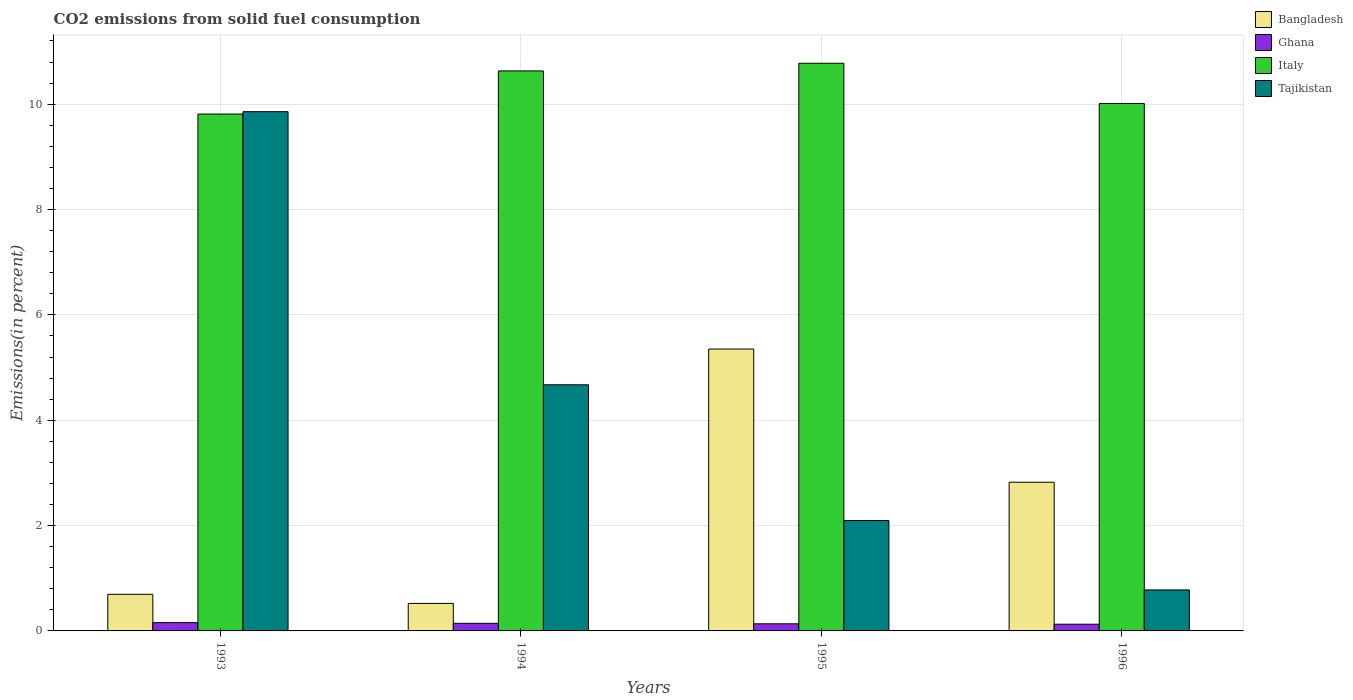How many groups of bars are there?
Give a very brief answer. 4. How many bars are there on the 3rd tick from the left?
Offer a very short reply. 4. How many bars are there on the 4th tick from the right?
Your answer should be compact. 4. What is the total CO2 emitted in Bangladesh in 1994?
Make the answer very short. 0.52. Across all years, what is the maximum total CO2 emitted in Tajikistan?
Your answer should be compact. 9.86. Across all years, what is the minimum total CO2 emitted in Ghana?
Offer a very short reply. 0.13. In which year was the total CO2 emitted in Italy minimum?
Provide a short and direct response. 1993. What is the total total CO2 emitted in Ghana in the graph?
Your answer should be compact. 0.56. What is the difference between the total CO2 emitted in Ghana in 1993 and that in 1996?
Keep it short and to the point. 0.03. What is the difference between the total CO2 emitted in Tajikistan in 1994 and the total CO2 emitted in Italy in 1995?
Make the answer very short. -6.1. What is the average total CO2 emitted in Tajikistan per year?
Provide a succinct answer. 4.35. In the year 1995, what is the difference between the total CO2 emitted in Tajikistan and total CO2 emitted in Italy?
Your answer should be compact. -8.68. In how many years, is the total CO2 emitted in Italy greater than 1.6 %?
Your answer should be very brief. 4. What is the ratio of the total CO2 emitted in Bangladesh in 1993 to that in 1994?
Your answer should be very brief. 1.33. What is the difference between the highest and the second highest total CO2 emitted in Italy?
Make the answer very short. 0.15. What is the difference between the highest and the lowest total CO2 emitted in Bangladesh?
Ensure brevity in your answer.  4.83. What does the 3rd bar from the right in 1993 represents?
Your response must be concise. Ghana. Is it the case that in every year, the sum of the total CO2 emitted in Ghana and total CO2 emitted in Tajikistan is greater than the total CO2 emitted in Bangladesh?
Give a very brief answer. No. How many bars are there?
Provide a short and direct response. 16. What is the difference between two consecutive major ticks on the Y-axis?
Keep it short and to the point. 2. Are the values on the major ticks of Y-axis written in scientific E-notation?
Your answer should be very brief. No. Does the graph contain any zero values?
Offer a very short reply. No. How many legend labels are there?
Give a very brief answer. 4. What is the title of the graph?
Make the answer very short. CO2 emissions from solid fuel consumption. What is the label or title of the Y-axis?
Keep it short and to the point. Emissions(in percent). What is the Emissions(in percent) in Bangladesh in 1993?
Offer a very short reply. 0.7. What is the Emissions(in percent) of Ghana in 1993?
Your answer should be very brief. 0.16. What is the Emissions(in percent) of Italy in 1993?
Give a very brief answer. 9.81. What is the Emissions(in percent) of Tajikistan in 1993?
Provide a succinct answer. 9.86. What is the Emissions(in percent) of Bangladesh in 1994?
Give a very brief answer. 0.52. What is the Emissions(in percent) in Ghana in 1994?
Offer a terse response. 0.14. What is the Emissions(in percent) in Italy in 1994?
Provide a short and direct response. 10.63. What is the Emissions(in percent) in Tajikistan in 1994?
Keep it short and to the point. 4.67. What is the Emissions(in percent) in Bangladesh in 1995?
Offer a terse response. 5.35. What is the Emissions(in percent) in Ghana in 1995?
Ensure brevity in your answer.  0.14. What is the Emissions(in percent) in Italy in 1995?
Make the answer very short. 10.78. What is the Emissions(in percent) of Tajikistan in 1995?
Your response must be concise. 2.1. What is the Emissions(in percent) in Bangladesh in 1996?
Offer a terse response. 2.82. What is the Emissions(in percent) in Ghana in 1996?
Your answer should be very brief. 0.13. What is the Emissions(in percent) in Italy in 1996?
Provide a succinct answer. 10.01. What is the Emissions(in percent) in Tajikistan in 1996?
Your answer should be very brief. 0.78. Across all years, what is the maximum Emissions(in percent) in Bangladesh?
Make the answer very short. 5.35. Across all years, what is the maximum Emissions(in percent) of Ghana?
Your answer should be very brief. 0.16. Across all years, what is the maximum Emissions(in percent) in Italy?
Make the answer very short. 10.78. Across all years, what is the maximum Emissions(in percent) of Tajikistan?
Your response must be concise. 9.86. Across all years, what is the minimum Emissions(in percent) of Bangladesh?
Offer a very short reply. 0.52. Across all years, what is the minimum Emissions(in percent) of Ghana?
Offer a terse response. 0.13. Across all years, what is the minimum Emissions(in percent) in Italy?
Provide a succinct answer. 9.81. Across all years, what is the minimum Emissions(in percent) of Tajikistan?
Make the answer very short. 0.78. What is the total Emissions(in percent) in Bangladesh in the graph?
Provide a succinct answer. 9.39. What is the total Emissions(in percent) in Ghana in the graph?
Keep it short and to the point. 0.56. What is the total Emissions(in percent) in Italy in the graph?
Your response must be concise. 41.24. What is the total Emissions(in percent) of Tajikistan in the graph?
Your answer should be very brief. 17.41. What is the difference between the Emissions(in percent) in Bangladesh in 1993 and that in 1994?
Give a very brief answer. 0.17. What is the difference between the Emissions(in percent) of Ghana in 1993 and that in 1994?
Offer a terse response. 0.01. What is the difference between the Emissions(in percent) in Italy in 1993 and that in 1994?
Your response must be concise. -0.82. What is the difference between the Emissions(in percent) of Tajikistan in 1993 and that in 1994?
Provide a short and direct response. 5.19. What is the difference between the Emissions(in percent) of Bangladesh in 1993 and that in 1995?
Keep it short and to the point. -4.66. What is the difference between the Emissions(in percent) of Ghana in 1993 and that in 1995?
Offer a very short reply. 0.02. What is the difference between the Emissions(in percent) in Italy in 1993 and that in 1995?
Provide a short and direct response. -0.96. What is the difference between the Emissions(in percent) of Tajikistan in 1993 and that in 1995?
Keep it short and to the point. 7.76. What is the difference between the Emissions(in percent) in Bangladesh in 1993 and that in 1996?
Keep it short and to the point. -2.13. What is the difference between the Emissions(in percent) in Ghana in 1993 and that in 1996?
Your answer should be very brief. 0.03. What is the difference between the Emissions(in percent) of Italy in 1993 and that in 1996?
Ensure brevity in your answer.  -0.2. What is the difference between the Emissions(in percent) in Tajikistan in 1993 and that in 1996?
Make the answer very short. 9.08. What is the difference between the Emissions(in percent) in Bangladesh in 1994 and that in 1995?
Make the answer very short. -4.83. What is the difference between the Emissions(in percent) in Ghana in 1994 and that in 1995?
Provide a succinct answer. 0.01. What is the difference between the Emissions(in percent) of Italy in 1994 and that in 1995?
Make the answer very short. -0.15. What is the difference between the Emissions(in percent) of Tajikistan in 1994 and that in 1995?
Give a very brief answer. 2.58. What is the difference between the Emissions(in percent) of Bangladesh in 1994 and that in 1996?
Make the answer very short. -2.3. What is the difference between the Emissions(in percent) in Ghana in 1994 and that in 1996?
Provide a short and direct response. 0.02. What is the difference between the Emissions(in percent) in Italy in 1994 and that in 1996?
Give a very brief answer. 0.62. What is the difference between the Emissions(in percent) in Tajikistan in 1994 and that in 1996?
Your response must be concise. 3.89. What is the difference between the Emissions(in percent) in Bangladesh in 1995 and that in 1996?
Ensure brevity in your answer.  2.53. What is the difference between the Emissions(in percent) in Ghana in 1995 and that in 1996?
Your answer should be compact. 0.01. What is the difference between the Emissions(in percent) of Italy in 1995 and that in 1996?
Give a very brief answer. 0.76. What is the difference between the Emissions(in percent) of Tajikistan in 1995 and that in 1996?
Your answer should be very brief. 1.32. What is the difference between the Emissions(in percent) of Bangladesh in 1993 and the Emissions(in percent) of Ghana in 1994?
Your answer should be compact. 0.55. What is the difference between the Emissions(in percent) in Bangladesh in 1993 and the Emissions(in percent) in Italy in 1994?
Offer a very short reply. -9.94. What is the difference between the Emissions(in percent) of Bangladesh in 1993 and the Emissions(in percent) of Tajikistan in 1994?
Keep it short and to the point. -3.98. What is the difference between the Emissions(in percent) in Ghana in 1993 and the Emissions(in percent) in Italy in 1994?
Make the answer very short. -10.47. What is the difference between the Emissions(in percent) of Ghana in 1993 and the Emissions(in percent) of Tajikistan in 1994?
Provide a short and direct response. -4.52. What is the difference between the Emissions(in percent) in Italy in 1993 and the Emissions(in percent) in Tajikistan in 1994?
Your answer should be very brief. 5.14. What is the difference between the Emissions(in percent) of Bangladesh in 1993 and the Emissions(in percent) of Ghana in 1995?
Keep it short and to the point. 0.56. What is the difference between the Emissions(in percent) of Bangladesh in 1993 and the Emissions(in percent) of Italy in 1995?
Make the answer very short. -10.08. What is the difference between the Emissions(in percent) in Bangladesh in 1993 and the Emissions(in percent) in Tajikistan in 1995?
Ensure brevity in your answer.  -1.4. What is the difference between the Emissions(in percent) in Ghana in 1993 and the Emissions(in percent) in Italy in 1995?
Offer a very short reply. -10.62. What is the difference between the Emissions(in percent) of Ghana in 1993 and the Emissions(in percent) of Tajikistan in 1995?
Your answer should be compact. -1.94. What is the difference between the Emissions(in percent) of Italy in 1993 and the Emissions(in percent) of Tajikistan in 1995?
Offer a very short reply. 7.72. What is the difference between the Emissions(in percent) of Bangladesh in 1993 and the Emissions(in percent) of Ghana in 1996?
Your answer should be very brief. 0.57. What is the difference between the Emissions(in percent) of Bangladesh in 1993 and the Emissions(in percent) of Italy in 1996?
Your answer should be very brief. -9.32. What is the difference between the Emissions(in percent) of Bangladesh in 1993 and the Emissions(in percent) of Tajikistan in 1996?
Ensure brevity in your answer.  -0.08. What is the difference between the Emissions(in percent) in Ghana in 1993 and the Emissions(in percent) in Italy in 1996?
Your answer should be compact. -9.86. What is the difference between the Emissions(in percent) in Ghana in 1993 and the Emissions(in percent) in Tajikistan in 1996?
Provide a succinct answer. -0.62. What is the difference between the Emissions(in percent) in Italy in 1993 and the Emissions(in percent) in Tajikistan in 1996?
Provide a short and direct response. 9.03. What is the difference between the Emissions(in percent) of Bangladesh in 1994 and the Emissions(in percent) of Ghana in 1995?
Provide a short and direct response. 0.39. What is the difference between the Emissions(in percent) of Bangladesh in 1994 and the Emissions(in percent) of Italy in 1995?
Provide a succinct answer. -10.26. What is the difference between the Emissions(in percent) of Bangladesh in 1994 and the Emissions(in percent) of Tajikistan in 1995?
Your answer should be compact. -1.57. What is the difference between the Emissions(in percent) of Ghana in 1994 and the Emissions(in percent) of Italy in 1995?
Give a very brief answer. -10.63. What is the difference between the Emissions(in percent) of Ghana in 1994 and the Emissions(in percent) of Tajikistan in 1995?
Make the answer very short. -1.95. What is the difference between the Emissions(in percent) in Italy in 1994 and the Emissions(in percent) in Tajikistan in 1995?
Provide a succinct answer. 8.54. What is the difference between the Emissions(in percent) in Bangladesh in 1994 and the Emissions(in percent) in Ghana in 1996?
Give a very brief answer. 0.39. What is the difference between the Emissions(in percent) of Bangladesh in 1994 and the Emissions(in percent) of Italy in 1996?
Your answer should be compact. -9.49. What is the difference between the Emissions(in percent) in Bangladesh in 1994 and the Emissions(in percent) in Tajikistan in 1996?
Keep it short and to the point. -0.26. What is the difference between the Emissions(in percent) of Ghana in 1994 and the Emissions(in percent) of Italy in 1996?
Keep it short and to the point. -9.87. What is the difference between the Emissions(in percent) of Ghana in 1994 and the Emissions(in percent) of Tajikistan in 1996?
Your response must be concise. -0.63. What is the difference between the Emissions(in percent) of Italy in 1994 and the Emissions(in percent) of Tajikistan in 1996?
Offer a terse response. 9.85. What is the difference between the Emissions(in percent) in Bangladesh in 1995 and the Emissions(in percent) in Ghana in 1996?
Provide a short and direct response. 5.22. What is the difference between the Emissions(in percent) in Bangladesh in 1995 and the Emissions(in percent) in Italy in 1996?
Your answer should be compact. -4.66. What is the difference between the Emissions(in percent) of Bangladesh in 1995 and the Emissions(in percent) of Tajikistan in 1996?
Give a very brief answer. 4.57. What is the difference between the Emissions(in percent) of Ghana in 1995 and the Emissions(in percent) of Italy in 1996?
Offer a very short reply. -9.88. What is the difference between the Emissions(in percent) in Ghana in 1995 and the Emissions(in percent) in Tajikistan in 1996?
Your answer should be compact. -0.64. What is the difference between the Emissions(in percent) in Italy in 1995 and the Emissions(in percent) in Tajikistan in 1996?
Keep it short and to the point. 10. What is the average Emissions(in percent) of Bangladesh per year?
Offer a terse response. 2.35. What is the average Emissions(in percent) of Ghana per year?
Offer a very short reply. 0.14. What is the average Emissions(in percent) in Italy per year?
Provide a succinct answer. 10.31. What is the average Emissions(in percent) of Tajikistan per year?
Provide a short and direct response. 4.35. In the year 1993, what is the difference between the Emissions(in percent) in Bangladesh and Emissions(in percent) in Ghana?
Your response must be concise. 0.54. In the year 1993, what is the difference between the Emissions(in percent) of Bangladesh and Emissions(in percent) of Italy?
Ensure brevity in your answer.  -9.12. In the year 1993, what is the difference between the Emissions(in percent) of Bangladesh and Emissions(in percent) of Tajikistan?
Give a very brief answer. -9.16. In the year 1993, what is the difference between the Emissions(in percent) in Ghana and Emissions(in percent) in Italy?
Give a very brief answer. -9.66. In the year 1993, what is the difference between the Emissions(in percent) of Ghana and Emissions(in percent) of Tajikistan?
Your answer should be very brief. -9.7. In the year 1993, what is the difference between the Emissions(in percent) in Italy and Emissions(in percent) in Tajikistan?
Offer a terse response. -0.05. In the year 1994, what is the difference between the Emissions(in percent) of Bangladesh and Emissions(in percent) of Ghana?
Keep it short and to the point. 0.38. In the year 1994, what is the difference between the Emissions(in percent) of Bangladesh and Emissions(in percent) of Italy?
Your response must be concise. -10.11. In the year 1994, what is the difference between the Emissions(in percent) of Bangladesh and Emissions(in percent) of Tajikistan?
Give a very brief answer. -4.15. In the year 1994, what is the difference between the Emissions(in percent) of Ghana and Emissions(in percent) of Italy?
Ensure brevity in your answer.  -10.49. In the year 1994, what is the difference between the Emissions(in percent) in Ghana and Emissions(in percent) in Tajikistan?
Your answer should be very brief. -4.53. In the year 1994, what is the difference between the Emissions(in percent) of Italy and Emissions(in percent) of Tajikistan?
Offer a very short reply. 5.96. In the year 1995, what is the difference between the Emissions(in percent) of Bangladesh and Emissions(in percent) of Ghana?
Ensure brevity in your answer.  5.22. In the year 1995, what is the difference between the Emissions(in percent) of Bangladesh and Emissions(in percent) of Italy?
Make the answer very short. -5.43. In the year 1995, what is the difference between the Emissions(in percent) of Bangladesh and Emissions(in percent) of Tajikistan?
Offer a terse response. 3.26. In the year 1995, what is the difference between the Emissions(in percent) in Ghana and Emissions(in percent) in Italy?
Offer a very short reply. -10.64. In the year 1995, what is the difference between the Emissions(in percent) in Ghana and Emissions(in percent) in Tajikistan?
Your response must be concise. -1.96. In the year 1995, what is the difference between the Emissions(in percent) in Italy and Emissions(in percent) in Tajikistan?
Provide a succinct answer. 8.68. In the year 1996, what is the difference between the Emissions(in percent) in Bangladesh and Emissions(in percent) in Ghana?
Your answer should be compact. 2.7. In the year 1996, what is the difference between the Emissions(in percent) in Bangladesh and Emissions(in percent) in Italy?
Provide a succinct answer. -7.19. In the year 1996, what is the difference between the Emissions(in percent) in Bangladesh and Emissions(in percent) in Tajikistan?
Your response must be concise. 2.04. In the year 1996, what is the difference between the Emissions(in percent) in Ghana and Emissions(in percent) in Italy?
Your answer should be compact. -9.89. In the year 1996, what is the difference between the Emissions(in percent) of Ghana and Emissions(in percent) of Tajikistan?
Your answer should be very brief. -0.65. In the year 1996, what is the difference between the Emissions(in percent) in Italy and Emissions(in percent) in Tajikistan?
Offer a very short reply. 9.24. What is the ratio of the Emissions(in percent) of Bangladesh in 1993 to that in 1994?
Offer a terse response. 1.33. What is the ratio of the Emissions(in percent) of Ghana in 1993 to that in 1994?
Provide a short and direct response. 1.09. What is the ratio of the Emissions(in percent) of Italy in 1993 to that in 1994?
Give a very brief answer. 0.92. What is the ratio of the Emissions(in percent) of Tajikistan in 1993 to that in 1994?
Offer a very short reply. 2.11. What is the ratio of the Emissions(in percent) in Bangladesh in 1993 to that in 1995?
Keep it short and to the point. 0.13. What is the ratio of the Emissions(in percent) in Ghana in 1993 to that in 1995?
Provide a short and direct response. 1.16. What is the ratio of the Emissions(in percent) in Italy in 1993 to that in 1995?
Make the answer very short. 0.91. What is the ratio of the Emissions(in percent) in Tajikistan in 1993 to that in 1995?
Give a very brief answer. 4.7. What is the ratio of the Emissions(in percent) of Bangladesh in 1993 to that in 1996?
Make the answer very short. 0.25. What is the ratio of the Emissions(in percent) of Ghana in 1993 to that in 1996?
Provide a succinct answer. 1.23. What is the ratio of the Emissions(in percent) of Italy in 1993 to that in 1996?
Offer a terse response. 0.98. What is the ratio of the Emissions(in percent) in Tajikistan in 1993 to that in 1996?
Offer a terse response. 12.67. What is the ratio of the Emissions(in percent) of Bangladesh in 1994 to that in 1995?
Offer a terse response. 0.1. What is the ratio of the Emissions(in percent) in Ghana in 1994 to that in 1995?
Ensure brevity in your answer.  1.07. What is the ratio of the Emissions(in percent) in Italy in 1994 to that in 1995?
Give a very brief answer. 0.99. What is the ratio of the Emissions(in percent) in Tajikistan in 1994 to that in 1995?
Offer a terse response. 2.23. What is the ratio of the Emissions(in percent) in Bangladesh in 1994 to that in 1996?
Give a very brief answer. 0.18. What is the ratio of the Emissions(in percent) in Ghana in 1994 to that in 1996?
Offer a terse response. 1.14. What is the ratio of the Emissions(in percent) in Italy in 1994 to that in 1996?
Your answer should be very brief. 1.06. What is the ratio of the Emissions(in percent) of Tajikistan in 1994 to that in 1996?
Offer a very short reply. 6. What is the ratio of the Emissions(in percent) of Bangladesh in 1995 to that in 1996?
Ensure brevity in your answer.  1.9. What is the ratio of the Emissions(in percent) in Ghana in 1995 to that in 1996?
Provide a short and direct response. 1.06. What is the ratio of the Emissions(in percent) in Italy in 1995 to that in 1996?
Your answer should be compact. 1.08. What is the ratio of the Emissions(in percent) of Tajikistan in 1995 to that in 1996?
Make the answer very short. 2.69. What is the difference between the highest and the second highest Emissions(in percent) in Bangladesh?
Your response must be concise. 2.53. What is the difference between the highest and the second highest Emissions(in percent) of Ghana?
Provide a short and direct response. 0.01. What is the difference between the highest and the second highest Emissions(in percent) in Italy?
Your answer should be compact. 0.15. What is the difference between the highest and the second highest Emissions(in percent) of Tajikistan?
Keep it short and to the point. 5.19. What is the difference between the highest and the lowest Emissions(in percent) of Bangladesh?
Keep it short and to the point. 4.83. What is the difference between the highest and the lowest Emissions(in percent) of Ghana?
Give a very brief answer. 0.03. What is the difference between the highest and the lowest Emissions(in percent) of Italy?
Keep it short and to the point. 0.96. What is the difference between the highest and the lowest Emissions(in percent) of Tajikistan?
Offer a terse response. 9.08. 